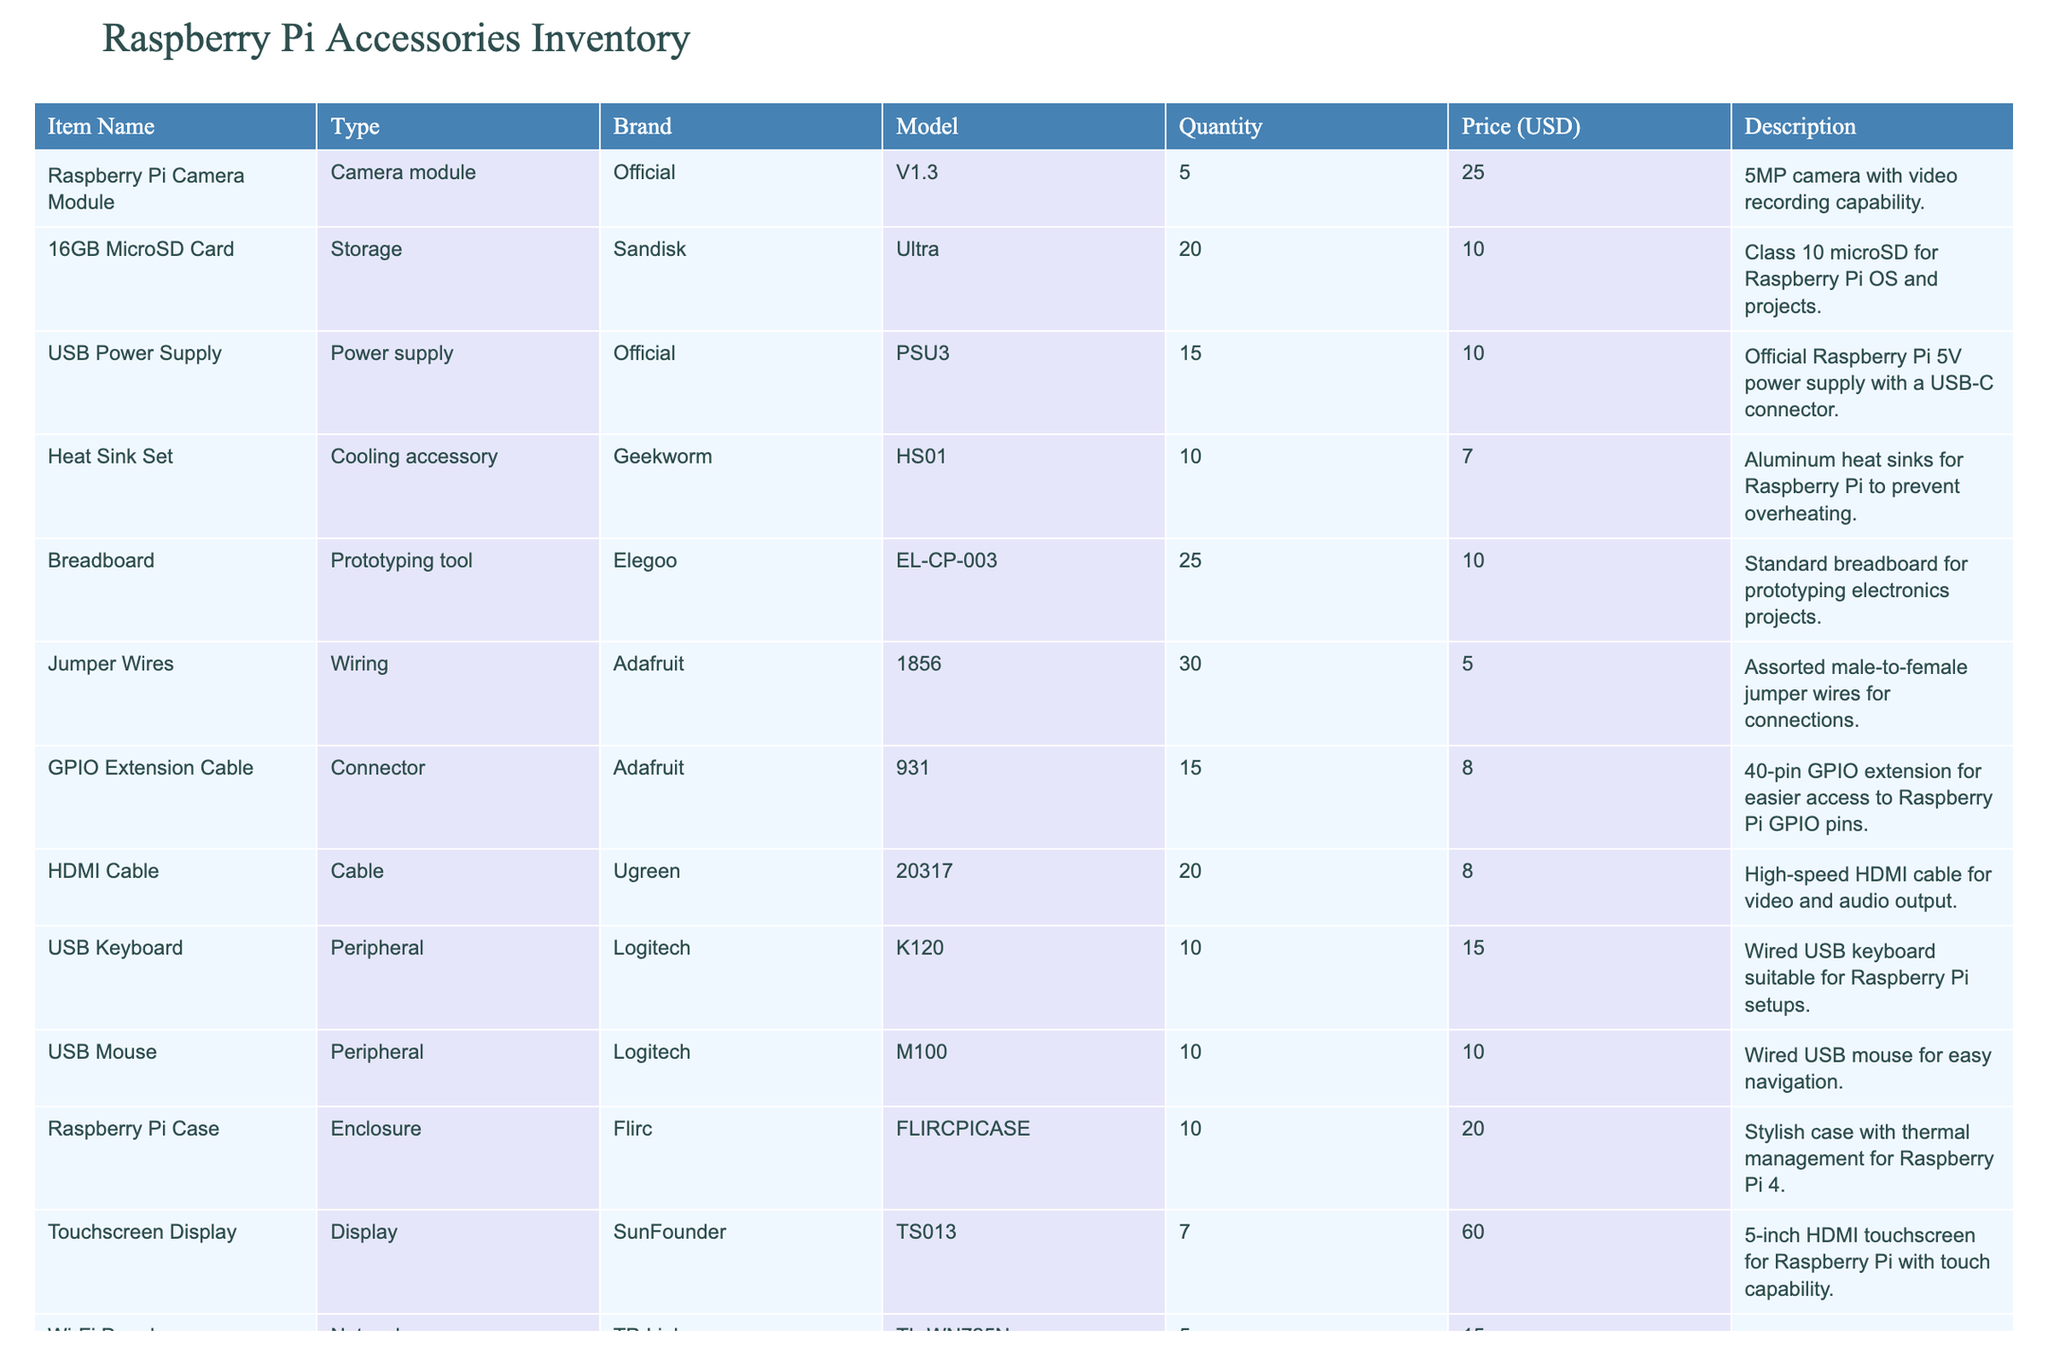What is the total quantity of HDMI cables available? There are 20 HDMI cables listed in the table under the "Quantity" column for the item "HDMI Cable".
Answer: 20 What is the price of the Raspberry Pi Camera Module? The table states that the price for the "Raspberry Pi Camera Module" is $25.00.
Answer: $25.00 Are there more Jumper Wires than 16GB MicroSD Cards? The table shows 1856 Jumper Wires and 20 MicroSD Cards, meaning there are indeed more Jumper Wires.
Answer: Yes What is the average price of all the items in the inventory? To calculate the average, first sum the prices ($25 + $10 + $10 + $7 + $10 + $5 + $8 + $8 + $15 + $10 + $20 + $60 + $15 + $50 + $25 + $35 + $15 + $4 = $363). There are 17 items, so the average price is $363 / 17 ≈ $21.35.
Answer: $21.35 Which item has the highest quantity in stock? The highest quantity listed is 1856 for "Jumper Wires" in the "Quantity" column.
Answer: Jumper Wires What is the total cost of all Raspberry Pi cases in inventory? There are 10 Raspberry Pi Cases, each priced at $20. Therefore, the total cost is calculated as 10 * $20 = $200.
Answer: $200 Is there a Servo Motor available at a price lower than $15? The table shows the Servo Motor priced at $15, so it is not available at a lower price.
Answer: No What is the combined quantity of all Power management and Network accessory items? The combined quantity is 4 (Power Switch HAT) + 5 (Wi-Fi Dongle) = 9.
Answer: 9 Which brand offers the largest variety of items listed in this inventory? The table contains items from various brands, but Official has 4 different items (Camera Module, Raspberry Pi, and Sense HAT, and Power Switch HAT), making it the brand with the most variety.
Answer: Official How many more storage devices are available than cooling accessories? The inventory shows 20 storage devices (16GB MicroSD Cards) and 10 cooling accessories (Heat Sink Set), resulting in a difference of 20 - 10 = 10.
Answer: 10 